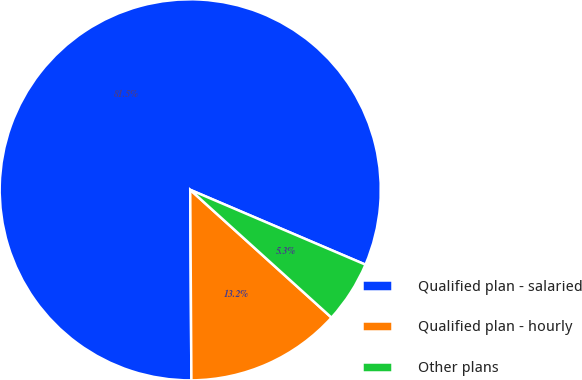Convert chart to OTSL. <chart><loc_0><loc_0><loc_500><loc_500><pie_chart><fcel>Qualified plan - salaried<fcel>Qualified plan - hourly<fcel>Other plans<nl><fcel>81.52%<fcel>13.2%<fcel>5.28%<nl></chart> 